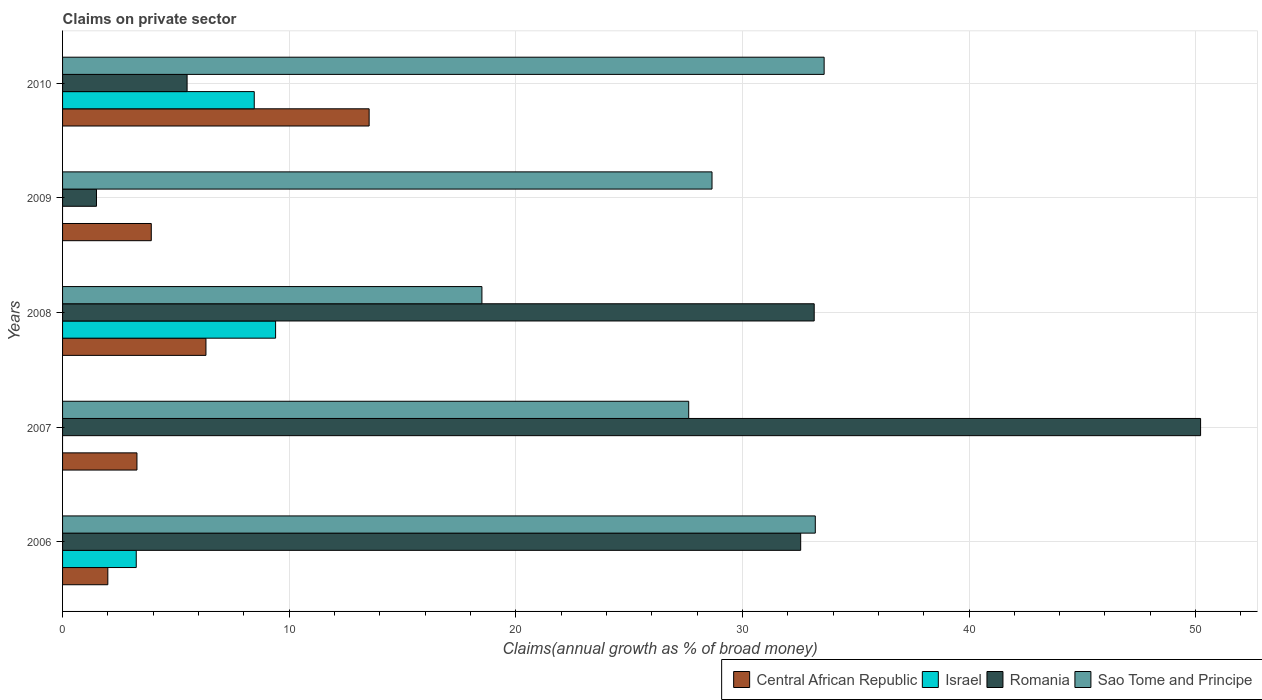How many different coloured bars are there?
Provide a succinct answer. 4. Are the number of bars per tick equal to the number of legend labels?
Offer a very short reply. No. Are the number of bars on each tick of the Y-axis equal?
Offer a very short reply. No. How many bars are there on the 1st tick from the bottom?
Your response must be concise. 4. Across all years, what is the maximum percentage of broad money claimed on private sector in Romania?
Ensure brevity in your answer.  50.22. Across all years, what is the minimum percentage of broad money claimed on private sector in Sao Tome and Principe?
Ensure brevity in your answer.  18.51. What is the total percentage of broad money claimed on private sector in Romania in the graph?
Keep it short and to the point. 122.95. What is the difference between the percentage of broad money claimed on private sector in Romania in 2006 and that in 2010?
Provide a short and direct response. 27.08. What is the difference between the percentage of broad money claimed on private sector in Sao Tome and Principe in 2010 and the percentage of broad money claimed on private sector in Central African Republic in 2009?
Your answer should be compact. 29.69. What is the average percentage of broad money claimed on private sector in Central African Republic per year?
Provide a succinct answer. 5.81. In the year 2007, what is the difference between the percentage of broad money claimed on private sector in Romania and percentage of broad money claimed on private sector in Central African Republic?
Ensure brevity in your answer.  46.94. In how many years, is the percentage of broad money claimed on private sector in Israel greater than 30 %?
Provide a short and direct response. 0. What is the ratio of the percentage of broad money claimed on private sector in Israel in 2006 to that in 2008?
Provide a succinct answer. 0.35. Is the percentage of broad money claimed on private sector in Sao Tome and Principe in 2008 less than that in 2009?
Your response must be concise. Yes. Is the difference between the percentage of broad money claimed on private sector in Romania in 2007 and 2009 greater than the difference between the percentage of broad money claimed on private sector in Central African Republic in 2007 and 2009?
Your answer should be compact. Yes. What is the difference between the highest and the second highest percentage of broad money claimed on private sector in Romania?
Ensure brevity in your answer.  17.05. What is the difference between the highest and the lowest percentage of broad money claimed on private sector in Central African Republic?
Your answer should be compact. 11.53. In how many years, is the percentage of broad money claimed on private sector in Israel greater than the average percentage of broad money claimed on private sector in Israel taken over all years?
Ensure brevity in your answer.  2. How many bars are there?
Your response must be concise. 18. Are the values on the major ticks of X-axis written in scientific E-notation?
Ensure brevity in your answer.  No. What is the title of the graph?
Your response must be concise. Claims on private sector. What is the label or title of the X-axis?
Offer a very short reply. Claims(annual growth as % of broad money). What is the Claims(annual growth as % of broad money) in Central African Republic in 2006?
Give a very brief answer. 2. What is the Claims(annual growth as % of broad money) in Israel in 2006?
Give a very brief answer. 3.25. What is the Claims(annual growth as % of broad money) of Romania in 2006?
Ensure brevity in your answer.  32.57. What is the Claims(annual growth as % of broad money) in Sao Tome and Principe in 2006?
Make the answer very short. 33.22. What is the Claims(annual growth as % of broad money) of Central African Republic in 2007?
Provide a short and direct response. 3.28. What is the Claims(annual growth as % of broad money) of Romania in 2007?
Your answer should be very brief. 50.22. What is the Claims(annual growth as % of broad money) of Sao Tome and Principe in 2007?
Your answer should be very brief. 27.63. What is the Claims(annual growth as % of broad money) of Central African Republic in 2008?
Give a very brief answer. 6.33. What is the Claims(annual growth as % of broad money) in Israel in 2008?
Your answer should be very brief. 9.4. What is the Claims(annual growth as % of broad money) of Romania in 2008?
Ensure brevity in your answer.  33.17. What is the Claims(annual growth as % of broad money) in Sao Tome and Principe in 2008?
Your answer should be very brief. 18.51. What is the Claims(annual growth as % of broad money) of Central African Republic in 2009?
Provide a short and direct response. 3.91. What is the Claims(annual growth as % of broad money) of Romania in 2009?
Make the answer very short. 1.5. What is the Claims(annual growth as % of broad money) of Sao Tome and Principe in 2009?
Your answer should be compact. 28.66. What is the Claims(annual growth as % of broad money) in Central African Republic in 2010?
Provide a short and direct response. 13.53. What is the Claims(annual growth as % of broad money) of Israel in 2010?
Your answer should be very brief. 8.46. What is the Claims(annual growth as % of broad money) in Romania in 2010?
Keep it short and to the point. 5.49. What is the Claims(annual growth as % of broad money) of Sao Tome and Principe in 2010?
Provide a short and direct response. 33.61. Across all years, what is the maximum Claims(annual growth as % of broad money) in Central African Republic?
Your response must be concise. 13.53. Across all years, what is the maximum Claims(annual growth as % of broad money) in Israel?
Make the answer very short. 9.4. Across all years, what is the maximum Claims(annual growth as % of broad money) in Romania?
Your response must be concise. 50.22. Across all years, what is the maximum Claims(annual growth as % of broad money) of Sao Tome and Principe?
Offer a very short reply. 33.61. Across all years, what is the minimum Claims(annual growth as % of broad money) of Central African Republic?
Provide a short and direct response. 2. Across all years, what is the minimum Claims(annual growth as % of broad money) in Romania?
Make the answer very short. 1.5. Across all years, what is the minimum Claims(annual growth as % of broad money) in Sao Tome and Principe?
Keep it short and to the point. 18.51. What is the total Claims(annual growth as % of broad money) of Central African Republic in the graph?
Your answer should be compact. 29.05. What is the total Claims(annual growth as % of broad money) of Israel in the graph?
Give a very brief answer. 21.11. What is the total Claims(annual growth as % of broad money) of Romania in the graph?
Ensure brevity in your answer.  122.95. What is the total Claims(annual growth as % of broad money) in Sao Tome and Principe in the graph?
Keep it short and to the point. 141.62. What is the difference between the Claims(annual growth as % of broad money) in Central African Republic in 2006 and that in 2007?
Offer a terse response. -1.29. What is the difference between the Claims(annual growth as % of broad money) in Romania in 2006 and that in 2007?
Your response must be concise. -17.65. What is the difference between the Claims(annual growth as % of broad money) of Sao Tome and Principe in 2006 and that in 2007?
Your response must be concise. 5.59. What is the difference between the Claims(annual growth as % of broad money) in Central African Republic in 2006 and that in 2008?
Offer a very short reply. -4.33. What is the difference between the Claims(annual growth as % of broad money) in Israel in 2006 and that in 2008?
Keep it short and to the point. -6.15. What is the difference between the Claims(annual growth as % of broad money) of Romania in 2006 and that in 2008?
Ensure brevity in your answer.  -0.6. What is the difference between the Claims(annual growth as % of broad money) in Sao Tome and Principe in 2006 and that in 2008?
Give a very brief answer. 14.71. What is the difference between the Claims(annual growth as % of broad money) of Central African Republic in 2006 and that in 2009?
Keep it short and to the point. -1.92. What is the difference between the Claims(annual growth as % of broad money) in Romania in 2006 and that in 2009?
Your answer should be compact. 31.08. What is the difference between the Claims(annual growth as % of broad money) in Sao Tome and Principe in 2006 and that in 2009?
Make the answer very short. 4.56. What is the difference between the Claims(annual growth as % of broad money) in Central African Republic in 2006 and that in 2010?
Make the answer very short. -11.53. What is the difference between the Claims(annual growth as % of broad money) of Israel in 2006 and that in 2010?
Give a very brief answer. -5.21. What is the difference between the Claims(annual growth as % of broad money) of Romania in 2006 and that in 2010?
Offer a terse response. 27.08. What is the difference between the Claims(annual growth as % of broad money) in Sao Tome and Principe in 2006 and that in 2010?
Make the answer very short. -0.39. What is the difference between the Claims(annual growth as % of broad money) of Central African Republic in 2007 and that in 2008?
Your response must be concise. -3.04. What is the difference between the Claims(annual growth as % of broad money) in Romania in 2007 and that in 2008?
Give a very brief answer. 17.05. What is the difference between the Claims(annual growth as % of broad money) of Sao Tome and Principe in 2007 and that in 2008?
Give a very brief answer. 9.12. What is the difference between the Claims(annual growth as % of broad money) in Central African Republic in 2007 and that in 2009?
Offer a very short reply. -0.63. What is the difference between the Claims(annual growth as % of broad money) in Romania in 2007 and that in 2009?
Make the answer very short. 48.72. What is the difference between the Claims(annual growth as % of broad money) of Sao Tome and Principe in 2007 and that in 2009?
Provide a succinct answer. -1.03. What is the difference between the Claims(annual growth as % of broad money) in Central African Republic in 2007 and that in 2010?
Your answer should be compact. -10.25. What is the difference between the Claims(annual growth as % of broad money) of Romania in 2007 and that in 2010?
Give a very brief answer. 44.72. What is the difference between the Claims(annual growth as % of broad money) of Sao Tome and Principe in 2007 and that in 2010?
Provide a succinct answer. -5.98. What is the difference between the Claims(annual growth as % of broad money) in Central African Republic in 2008 and that in 2009?
Provide a succinct answer. 2.41. What is the difference between the Claims(annual growth as % of broad money) in Romania in 2008 and that in 2009?
Offer a very short reply. 31.67. What is the difference between the Claims(annual growth as % of broad money) of Sao Tome and Principe in 2008 and that in 2009?
Keep it short and to the point. -10.15. What is the difference between the Claims(annual growth as % of broad money) of Central African Republic in 2008 and that in 2010?
Your response must be concise. -7.2. What is the difference between the Claims(annual growth as % of broad money) of Israel in 2008 and that in 2010?
Your answer should be compact. 0.94. What is the difference between the Claims(annual growth as % of broad money) in Romania in 2008 and that in 2010?
Your response must be concise. 27.67. What is the difference between the Claims(annual growth as % of broad money) of Sao Tome and Principe in 2008 and that in 2010?
Offer a terse response. -15.1. What is the difference between the Claims(annual growth as % of broad money) in Central African Republic in 2009 and that in 2010?
Ensure brevity in your answer.  -9.61. What is the difference between the Claims(annual growth as % of broad money) of Romania in 2009 and that in 2010?
Give a very brief answer. -4. What is the difference between the Claims(annual growth as % of broad money) of Sao Tome and Principe in 2009 and that in 2010?
Make the answer very short. -4.95. What is the difference between the Claims(annual growth as % of broad money) of Central African Republic in 2006 and the Claims(annual growth as % of broad money) of Romania in 2007?
Provide a succinct answer. -48.22. What is the difference between the Claims(annual growth as % of broad money) in Central African Republic in 2006 and the Claims(annual growth as % of broad money) in Sao Tome and Principe in 2007?
Provide a succinct answer. -25.63. What is the difference between the Claims(annual growth as % of broad money) of Israel in 2006 and the Claims(annual growth as % of broad money) of Romania in 2007?
Keep it short and to the point. -46.97. What is the difference between the Claims(annual growth as % of broad money) in Israel in 2006 and the Claims(annual growth as % of broad money) in Sao Tome and Principe in 2007?
Provide a short and direct response. -24.38. What is the difference between the Claims(annual growth as % of broad money) of Romania in 2006 and the Claims(annual growth as % of broad money) of Sao Tome and Principe in 2007?
Your answer should be compact. 4.94. What is the difference between the Claims(annual growth as % of broad money) of Central African Republic in 2006 and the Claims(annual growth as % of broad money) of Israel in 2008?
Ensure brevity in your answer.  -7.4. What is the difference between the Claims(annual growth as % of broad money) in Central African Republic in 2006 and the Claims(annual growth as % of broad money) in Romania in 2008?
Keep it short and to the point. -31.17. What is the difference between the Claims(annual growth as % of broad money) of Central African Republic in 2006 and the Claims(annual growth as % of broad money) of Sao Tome and Principe in 2008?
Provide a succinct answer. -16.51. What is the difference between the Claims(annual growth as % of broad money) of Israel in 2006 and the Claims(annual growth as % of broad money) of Romania in 2008?
Give a very brief answer. -29.92. What is the difference between the Claims(annual growth as % of broad money) in Israel in 2006 and the Claims(annual growth as % of broad money) in Sao Tome and Principe in 2008?
Provide a short and direct response. -15.25. What is the difference between the Claims(annual growth as % of broad money) in Romania in 2006 and the Claims(annual growth as % of broad money) in Sao Tome and Principe in 2008?
Offer a terse response. 14.07. What is the difference between the Claims(annual growth as % of broad money) in Central African Republic in 2006 and the Claims(annual growth as % of broad money) in Romania in 2009?
Make the answer very short. 0.5. What is the difference between the Claims(annual growth as % of broad money) in Central African Republic in 2006 and the Claims(annual growth as % of broad money) in Sao Tome and Principe in 2009?
Offer a very short reply. -26.66. What is the difference between the Claims(annual growth as % of broad money) of Israel in 2006 and the Claims(annual growth as % of broad money) of Romania in 2009?
Provide a short and direct response. 1.75. What is the difference between the Claims(annual growth as % of broad money) in Israel in 2006 and the Claims(annual growth as % of broad money) in Sao Tome and Principe in 2009?
Make the answer very short. -25.41. What is the difference between the Claims(annual growth as % of broad money) in Romania in 2006 and the Claims(annual growth as % of broad money) in Sao Tome and Principe in 2009?
Keep it short and to the point. 3.91. What is the difference between the Claims(annual growth as % of broad money) of Central African Republic in 2006 and the Claims(annual growth as % of broad money) of Israel in 2010?
Make the answer very short. -6.46. What is the difference between the Claims(annual growth as % of broad money) in Central African Republic in 2006 and the Claims(annual growth as % of broad money) in Romania in 2010?
Keep it short and to the point. -3.5. What is the difference between the Claims(annual growth as % of broad money) of Central African Republic in 2006 and the Claims(annual growth as % of broad money) of Sao Tome and Principe in 2010?
Your response must be concise. -31.61. What is the difference between the Claims(annual growth as % of broad money) of Israel in 2006 and the Claims(annual growth as % of broad money) of Romania in 2010?
Make the answer very short. -2.24. What is the difference between the Claims(annual growth as % of broad money) of Israel in 2006 and the Claims(annual growth as % of broad money) of Sao Tome and Principe in 2010?
Offer a terse response. -30.36. What is the difference between the Claims(annual growth as % of broad money) in Romania in 2006 and the Claims(annual growth as % of broad money) in Sao Tome and Principe in 2010?
Provide a short and direct response. -1.03. What is the difference between the Claims(annual growth as % of broad money) in Central African Republic in 2007 and the Claims(annual growth as % of broad money) in Israel in 2008?
Provide a short and direct response. -6.12. What is the difference between the Claims(annual growth as % of broad money) in Central African Republic in 2007 and the Claims(annual growth as % of broad money) in Romania in 2008?
Give a very brief answer. -29.89. What is the difference between the Claims(annual growth as % of broad money) in Central African Republic in 2007 and the Claims(annual growth as % of broad money) in Sao Tome and Principe in 2008?
Keep it short and to the point. -15.22. What is the difference between the Claims(annual growth as % of broad money) in Romania in 2007 and the Claims(annual growth as % of broad money) in Sao Tome and Principe in 2008?
Provide a short and direct response. 31.71. What is the difference between the Claims(annual growth as % of broad money) of Central African Republic in 2007 and the Claims(annual growth as % of broad money) of Romania in 2009?
Offer a very short reply. 1.79. What is the difference between the Claims(annual growth as % of broad money) in Central African Republic in 2007 and the Claims(annual growth as % of broad money) in Sao Tome and Principe in 2009?
Offer a very short reply. -25.38. What is the difference between the Claims(annual growth as % of broad money) of Romania in 2007 and the Claims(annual growth as % of broad money) of Sao Tome and Principe in 2009?
Offer a very short reply. 21.56. What is the difference between the Claims(annual growth as % of broad money) of Central African Republic in 2007 and the Claims(annual growth as % of broad money) of Israel in 2010?
Offer a terse response. -5.18. What is the difference between the Claims(annual growth as % of broad money) in Central African Republic in 2007 and the Claims(annual growth as % of broad money) in Romania in 2010?
Keep it short and to the point. -2.21. What is the difference between the Claims(annual growth as % of broad money) in Central African Republic in 2007 and the Claims(annual growth as % of broad money) in Sao Tome and Principe in 2010?
Provide a succinct answer. -30.32. What is the difference between the Claims(annual growth as % of broad money) in Romania in 2007 and the Claims(annual growth as % of broad money) in Sao Tome and Principe in 2010?
Make the answer very short. 16.61. What is the difference between the Claims(annual growth as % of broad money) in Central African Republic in 2008 and the Claims(annual growth as % of broad money) in Romania in 2009?
Your answer should be compact. 4.83. What is the difference between the Claims(annual growth as % of broad money) of Central African Republic in 2008 and the Claims(annual growth as % of broad money) of Sao Tome and Principe in 2009?
Your response must be concise. -22.33. What is the difference between the Claims(annual growth as % of broad money) of Israel in 2008 and the Claims(annual growth as % of broad money) of Romania in 2009?
Give a very brief answer. 7.9. What is the difference between the Claims(annual growth as % of broad money) of Israel in 2008 and the Claims(annual growth as % of broad money) of Sao Tome and Principe in 2009?
Provide a succinct answer. -19.26. What is the difference between the Claims(annual growth as % of broad money) in Romania in 2008 and the Claims(annual growth as % of broad money) in Sao Tome and Principe in 2009?
Your answer should be very brief. 4.51. What is the difference between the Claims(annual growth as % of broad money) of Central African Republic in 2008 and the Claims(annual growth as % of broad money) of Israel in 2010?
Offer a very short reply. -2.13. What is the difference between the Claims(annual growth as % of broad money) in Central African Republic in 2008 and the Claims(annual growth as % of broad money) in Romania in 2010?
Your answer should be very brief. 0.83. What is the difference between the Claims(annual growth as % of broad money) in Central African Republic in 2008 and the Claims(annual growth as % of broad money) in Sao Tome and Principe in 2010?
Offer a very short reply. -27.28. What is the difference between the Claims(annual growth as % of broad money) of Israel in 2008 and the Claims(annual growth as % of broad money) of Romania in 2010?
Give a very brief answer. 3.91. What is the difference between the Claims(annual growth as % of broad money) of Israel in 2008 and the Claims(annual growth as % of broad money) of Sao Tome and Principe in 2010?
Offer a terse response. -24.21. What is the difference between the Claims(annual growth as % of broad money) of Romania in 2008 and the Claims(annual growth as % of broad money) of Sao Tome and Principe in 2010?
Offer a terse response. -0.44. What is the difference between the Claims(annual growth as % of broad money) in Central African Republic in 2009 and the Claims(annual growth as % of broad money) in Israel in 2010?
Keep it short and to the point. -4.54. What is the difference between the Claims(annual growth as % of broad money) in Central African Republic in 2009 and the Claims(annual growth as % of broad money) in Romania in 2010?
Offer a terse response. -1.58. What is the difference between the Claims(annual growth as % of broad money) of Central African Republic in 2009 and the Claims(annual growth as % of broad money) of Sao Tome and Principe in 2010?
Give a very brief answer. -29.69. What is the difference between the Claims(annual growth as % of broad money) of Romania in 2009 and the Claims(annual growth as % of broad money) of Sao Tome and Principe in 2010?
Ensure brevity in your answer.  -32.11. What is the average Claims(annual growth as % of broad money) of Central African Republic per year?
Keep it short and to the point. 5.81. What is the average Claims(annual growth as % of broad money) in Israel per year?
Keep it short and to the point. 4.22. What is the average Claims(annual growth as % of broad money) in Romania per year?
Give a very brief answer. 24.59. What is the average Claims(annual growth as % of broad money) in Sao Tome and Principe per year?
Your response must be concise. 28.32. In the year 2006, what is the difference between the Claims(annual growth as % of broad money) in Central African Republic and Claims(annual growth as % of broad money) in Israel?
Offer a very short reply. -1.25. In the year 2006, what is the difference between the Claims(annual growth as % of broad money) in Central African Republic and Claims(annual growth as % of broad money) in Romania?
Provide a short and direct response. -30.58. In the year 2006, what is the difference between the Claims(annual growth as % of broad money) of Central African Republic and Claims(annual growth as % of broad money) of Sao Tome and Principe?
Offer a terse response. -31.22. In the year 2006, what is the difference between the Claims(annual growth as % of broad money) in Israel and Claims(annual growth as % of broad money) in Romania?
Your response must be concise. -29.32. In the year 2006, what is the difference between the Claims(annual growth as % of broad money) in Israel and Claims(annual growth as % of broad money) in Sao Tome and Principe?
Your answer should be compact. -29.97. In the year 2006, what is the difference between the Claims(annual growth as % of broad money) in Romania and Claims(annual growth as % of broad money) in Sao Tome and Principe?
Give a very brief answer. -0.64. In the year 2007, what is the difference between the Claims(annual growth as % of broad money) in Central African Republic and Claims(annual growth as % of broad money) in Romania?
Give a very brief answer. -46.94. In the year 2007, what is the difference between the Claims(annual growth as % of broad money) of Central African Republic and Claims(annual growth as % of broad money) of Sao Tome and Principe?
Make the answer very short. -24.35. In the year 2007, what is the difference between the Claims(annual growth as % of broad money) of Romania and Claims(annual growth as % of broad money) of Sao Tome and Principe?
Ensure brevity in your answer.  22.59. In the year 2008, what is the difference between the Claims(annual growth as % of broad money) of Central African Republic and Claims(annual growth as % of broad money) of Israel?
Offer a terse response. -3.07. In the year 2008, what is the difference between the Claims(annual growth as % of broad money) in Central African Republic and Claims(annual growth as % of broad money) in Romania?
Ensure brevity in your answer.  -26.84. In the year 2008, what is the difference between the Claims(annual growth as % of broad money) in Central African Republic and Claims(annual growth as % of broad money) in Sao Tome and Principe?
Provide a succinct answer. -12.18. In the year 2008, what is the difference between the Claims(annual growth as % of broad money) in Israel and Claims(annual growth as % of broad money) in Romania?
Your answer should be compact. -23.77. In the year 2008, what is the difference between the Claims(annual growth as % of broad money) of Israel and Claims(annual growth as % of broad money) of Sao Tome and Principe?
Your answer should be very brief. -9.1. In the year 2008, what is the difference between the Claims(annual growth as % of broad money) in Romania and Claims(annual growth as % of broad money) in Sao Tome and Principe?
Your answer should be compact. 14.66. In the year 2009, what is the difference between the Claims(annual growth as % of broad money) in Central African Republic and Claims(annual growth as % of broad money) in Romania?
Provide a succinct answer. 2.42. In the year 2009, what is the difference between the Claims(annual growth as % of broad money) in Central African Republic and Claims(annual growth as % of broad money) in Sao Tome and Principe?
Provide a short and direct response. -24.74. In the year 2009, what is the difference between the Claims(annual growth as % of broad money) in Romania and Claims(annual growth as % of broad money) in Sao Tome and Principe?
Your answer should be very brief. -27.16. In the year 2010, what is the difference between the Claims(annual growth as % of broad money) in Central African Republic and Claims(annual growth as % of broad money) in Israel?
Provide a succinct answer. 5.07. In the year 2010, what is the difference between the Claims(annual growth as % of broad money) of Central African Republic and Claims(annual growth as % of broad money) of Romania?
Your response must be concise. 8.03. In the year 2010, what is the difference between the Claims(annual growth as % of broad money) of Central African Republic and Claims(annual growth as % of broad money) of Sao Tome and Principe?
Give a very brief answer. -20.08. In the year 2010, what is the difference between the Claims(annual growth as % of broad money) of Israel and Claims(annual growth as % of broad money) of Romania?
Offer a very short reply. 2.96. In the year 2010, what is the difference between the Claims(annual growth as % of broad money) of Israel and Claims(annual growth as % of broad money) of Sao Tome and Principe?
Provide a succinct answer. -25.15. In the year 2010, what is the difference between the Claims(annual growth as % of broad money) in Romania and Claims(annual growth as % of broad money) in Sao Tome and Principe?
Provide a succinct answer. -28.11. What is the ratio of the Claims(annual growth as % of broad money) in Central African Republic in 2006 to that in 2007?
Make the answer very short. 0.61. What is the ratio of the Claims(annual growth as % of broad money) of Romania in 2006 to that in 2007?
Your answer should be compact. 0.65. What is the ratio of the Claims(annual growth as % of broad money) in Sao Tome and Principe in 2006 to that in 2007?
Your answer should be very brief. 1.2. What is the ratio of the Claims(annual growth as % of broad money) of Central African Republic in 2006 to that in 2008?
Your answer should be very brief. 0.32. What is the ratio of the Claims(annual growth as % of broad money) in Israel in 2006 to that in 2008?
Make the answer very short. 0.35. What is the ratio of the Claims(annual growth as % of broad money) in Sao Tome and Principe in 2006 to that in 2008?
Your answer should be compact. 1.79. What is the ratio of the Claims(annual growth as % of broad money) in Central African Republic in 2006 to that in 2009?
Your answer should be very brief. 0.51. What is the ratio of the Claims(annual growth as % of broad money) in Romania in 2006 to that in 2009?
Keep it short and to the point. 21.76. What is the ratio of the Claims(annual growth as % of broad money) of Sao Tome and Principe in 2006 to that in 2009?
Offer a very short reply. 1.16. What is the ratio of the Claims(annual growth as % of broad money) in Central African Republic in 2006 to that in 2010?
Your response must be concise. 0.15. What is the ratio of the Claims(annual growth as % of broad money) of Israel in 2006 to that in 2010?
Offer a very short reply. 0.38. What is the ratio of the Claims(annual growth as % of broad money) of Romania in 2006 to that in 2010?
Your answer should be compact. 5.93. What is the ratio of the Claims(annual growth as % of broad money) in Sao Tome and Principe in 2006 to that in 2010?
Your answer should be very brief. 0.99. What is the ratio of the Claims(annual growth as % of broad money) of Central African Republic in 2007 to that in 2008?
Offer a very short reply. 0.52. What is the ratio of the Claims(annual growth as % of broad money) in Romania in 2007 to that in 2008?
Your answer should be compact. 1.51. What is the ratio of the Claims(annual growth as % of broad money) in Sao Tome and Principe in 2007 to that in 2008?
Offer a terse response. 1.49. What is the ratio of the Claims(annual growth as % of broad money) in Central African Republic in 2007 to that in 2009?
Your response must be concise. 0.84. What is the ratio of the Claims(annual growth as % of broad money) of Romania in 2007 to that in 2009?
Keep it short and to the point. 33.55. What is the ratio of the Claims(annual growth as % of broad money) in Sao Tome and Principe in 2007 to that in 2009?
Offer a terse response. 0.96. What is the ratio of the Claims(annual growth as % of broad money) in Central African Republic in 2007 to that in 2010?
Your answer should be compact. 0.24. What is the ratio of the Claims(annual growth as % of broad money) in Romania in 2007 to that in 2010?
Your response must be concise. 9.14. What is the ratio of the Claims(annual growth as % of broad money) in Sao Tome and Principe in 2007 to that in 2010?
Offer a terse response. 0.82. What is the ratio of the Claims(annual growth as % of broad money) of Central African Republic in 2008 to that in 2009?
Offer a very short reply. 1.62. What is the ratio of the Claims(annual growth as % of broad money) of Romania in 2008 to that in 2009?
Your answer should be very brief. 22.16. What is the ratio of the Claims(annual growth as % of broad money) in Sao Tome and Principe in 2008 to that in 2009?
Your answer should be very brief. 0.65. What is the ratio of the Claims(annual growth as % of broad money) of Central African Republic in 2008 to that in 2010?
Ensure brevity in your answer.  0.47. What is the ratio of the Claims(annual growth as % of broad money) of Israel in 2008 to that in 2010?
Make the answer very short. 1.11. What is the ratio of the Claims(annual growth as % of broad money) in Romania in 2008 to that in 2010?
Offer a terse response. 6.04. What is the ratio of the Claims(annual growth as % of broad money) of Sao Tome and Principe in 2008 to that in 2010?
Keep it short and to the point. 0.55. What is the ratio of the Claims(annual growth as % of broad money) of Central African Republic in 2009 to that in 2010?
Offer a very short reply. 0.29. What is the ratio of the Claims(annual growth as % of broad money) of Romania in 2009 to that in 2010?
Provide a short and direct response. 0.27. What is the ratio of the Claims(annual growth as % of broad money) of Sao Tome and Principe in 2009 to that in 2010?
Provide a short and direct response. 0.85. What is the difference between the highest and the second highest Claims(annual growth as % of broad money) in Central African Republic?
Offer a very short reply. 7.2. What is the difference between the highest and the second highest Claims(annual growth as % of broad money) in Israel?
Make the answer very short. 0.94. What is the difference between the highest and the second highest Claims(annual growth as % of broad money) in Romania?
Keep it short and to the point. 17.05. What is the difference between the highest and the second highest Claims(annual growth as % of broad money) in Sao Tome and Principe?
Offer a very short reply. 0.39. What is the difference between the highest and the lowest Claims(annual growth as % of broad money) in Central African Republic?
Provide a succinct answer. 11.53. What is the difference between the highest and the lowest Claims(annual growth as % of broad money) in Israel?
Provide a succinct answer. 9.4. What is the difference between the highest and the lowest Claims(annual growth as % of broad money) of Romania?
Keep it short and to the point. 48.72. What is the difference between the highest and the lowest Claims(annual growth as % of broad money) of Sao Tome and Principe?
Ensure brevity in your answer.  15.1. 